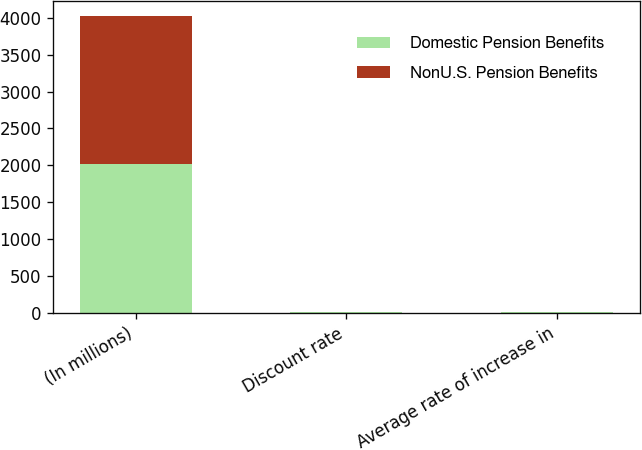Convert chart to OTSL. <chart><loc_0><loc_0><loc_500><loc_500><stacked_bar_chart><ecel><fcel>(In millions)<fcel>Discount rate<fcel>Average rate of increase in<nl><fcel>Domestic Pension Benefits<fcel>2011<fcel>4.5<fcel>4<nl><fcel>NonU.S. Pension Benefits<fcel>2011<fcel>4.37<fcel>3.08<nl></chart> 